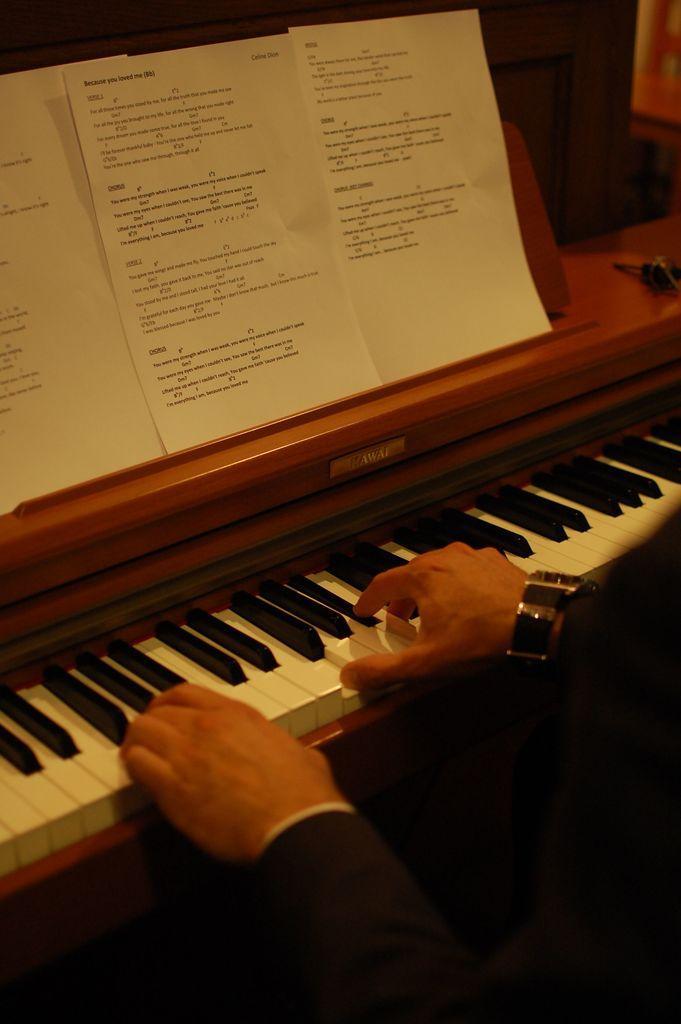Please provide a concise description of this image. There is a person playing piano and there are three papers in front of him. 